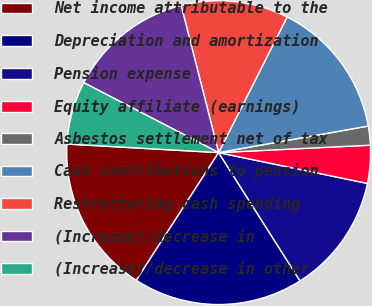Convert chart to OTSL. <chart><loc_0><loc_0><loc_500><loc_500><pie_chart><fcel>Net income attributable to the<fcel>Depreciation and amortization<fcel>Pension expense<fcel>Equity affiliate (earnings)<fcel>Asbestos settlement net of tax<fcel>Cash contributions to pension<fcel>Restructuring cash spending<fcel>(Increase)/decrease in<fcel>(Increase)/decrease in other<nl><fcel>16.78%<fcel>18.12%<fcel>12.75%<fcel>4.03%<fcel>2.02%<fcel>14.76%<fcel>11.41%<fcel>13.42%<fcel>6.71%<nl></chart> 